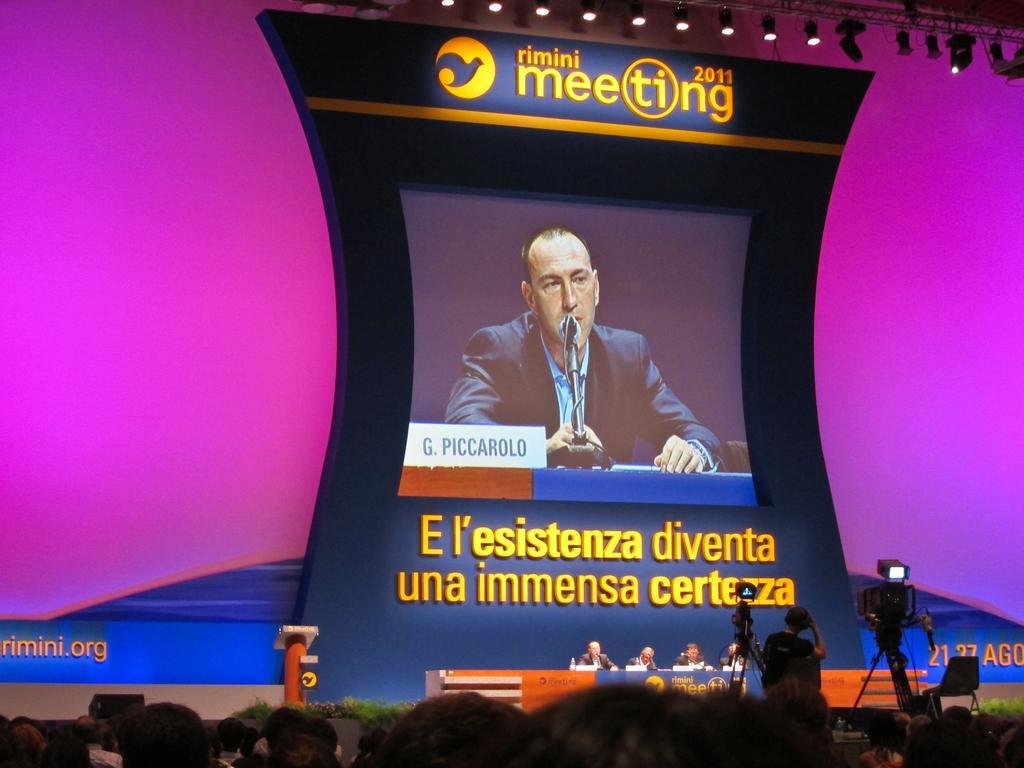Describe this image in one or two sentences. In the center of the image we can see screen. At the bottom of the image we can see dais, persons, crowd, cameras. In the background there is wall. 